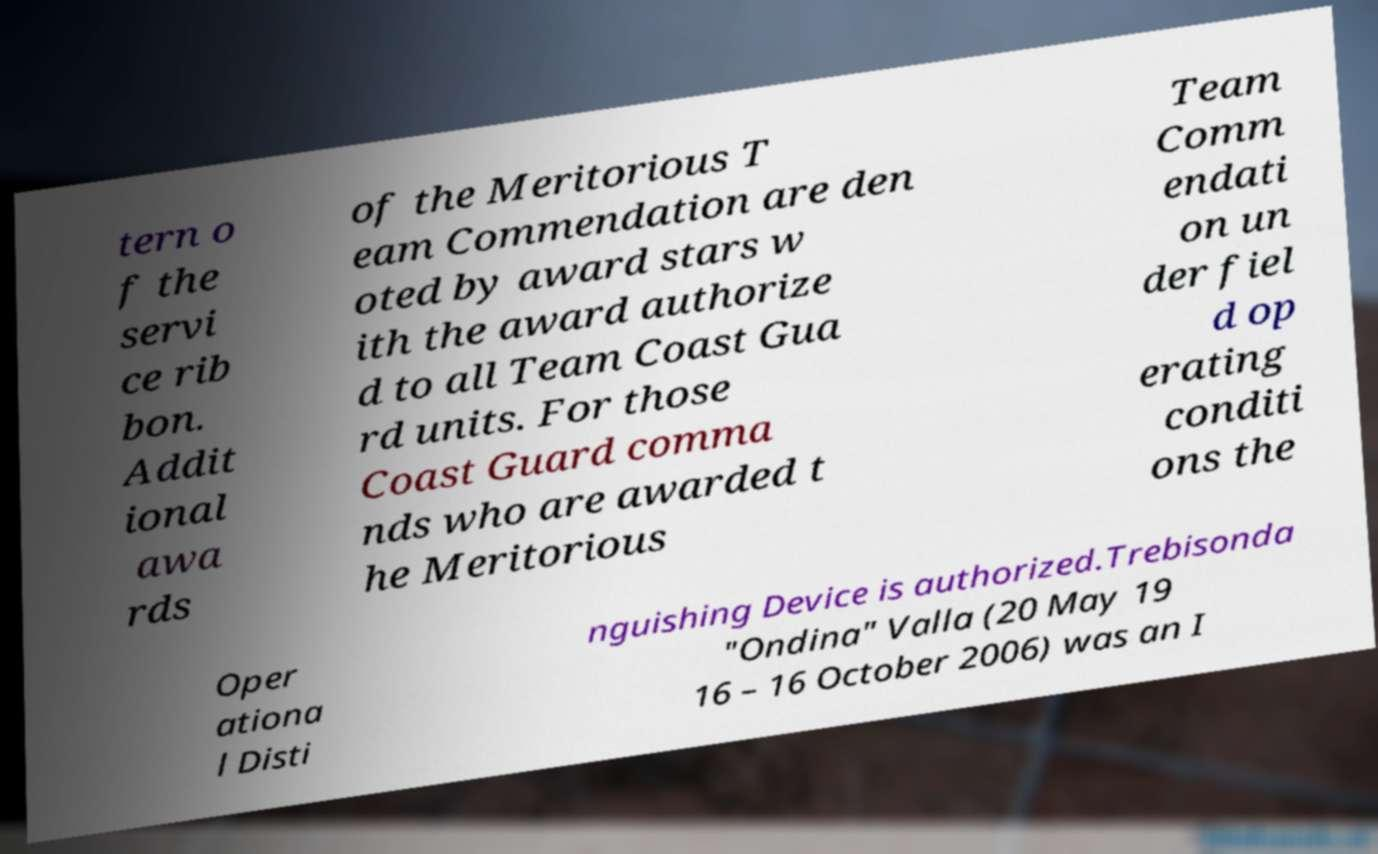Could you assist in decoding the text presented in this image and type it out clearly? tern o f the servi ce rib bon. Addit ional awa rds of the Meritorious T eam Commendation are den oted by award stars w ith the award authorize d to all Team Coast Gua rd units. For those Coast Guard comma nds who are awarded t he Meritorious Team Comm endati on un der fiel d op erating conditi ons the Oper ationa l Disti nguishing Device is authorized.Trebisonda "Ondina" Valla (20 May 19 16 – 16 October 2006) was an I 